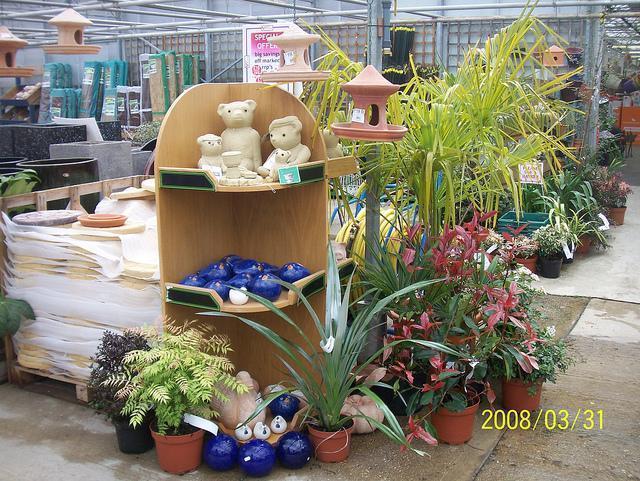What kind of animal is on the top shelf?
Pick the correct solution from the four options below to address the question.
Options: Mouse, ant, bear, cat. Bear. 